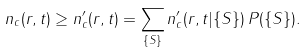Convert formula to latex. <formula><loc_0><loc_0><loc_500><loc_500>n _ { c } ( { r } , t ) \geq n ^ { \prime } _ { c } ( { r } , t ) = \sum _ { \{ S \} } n ^ { \prime } _ { c } ( { r } , t | \{ S \} ) \, P ( \{ S \} ) .</formula> 